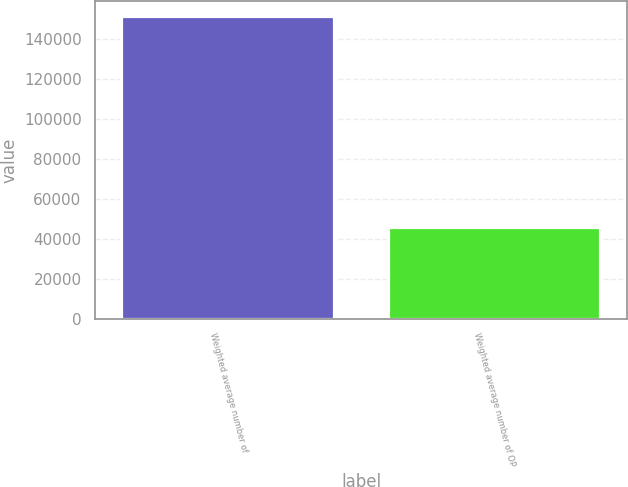<chart> <loc_0><loc_0><loc_500><loc_500><bar_chart><fcel>Weighted average number of<fcel>Weighted average number of OP<nl><fcel>151070<fcel>45651.3<nl></chart> 